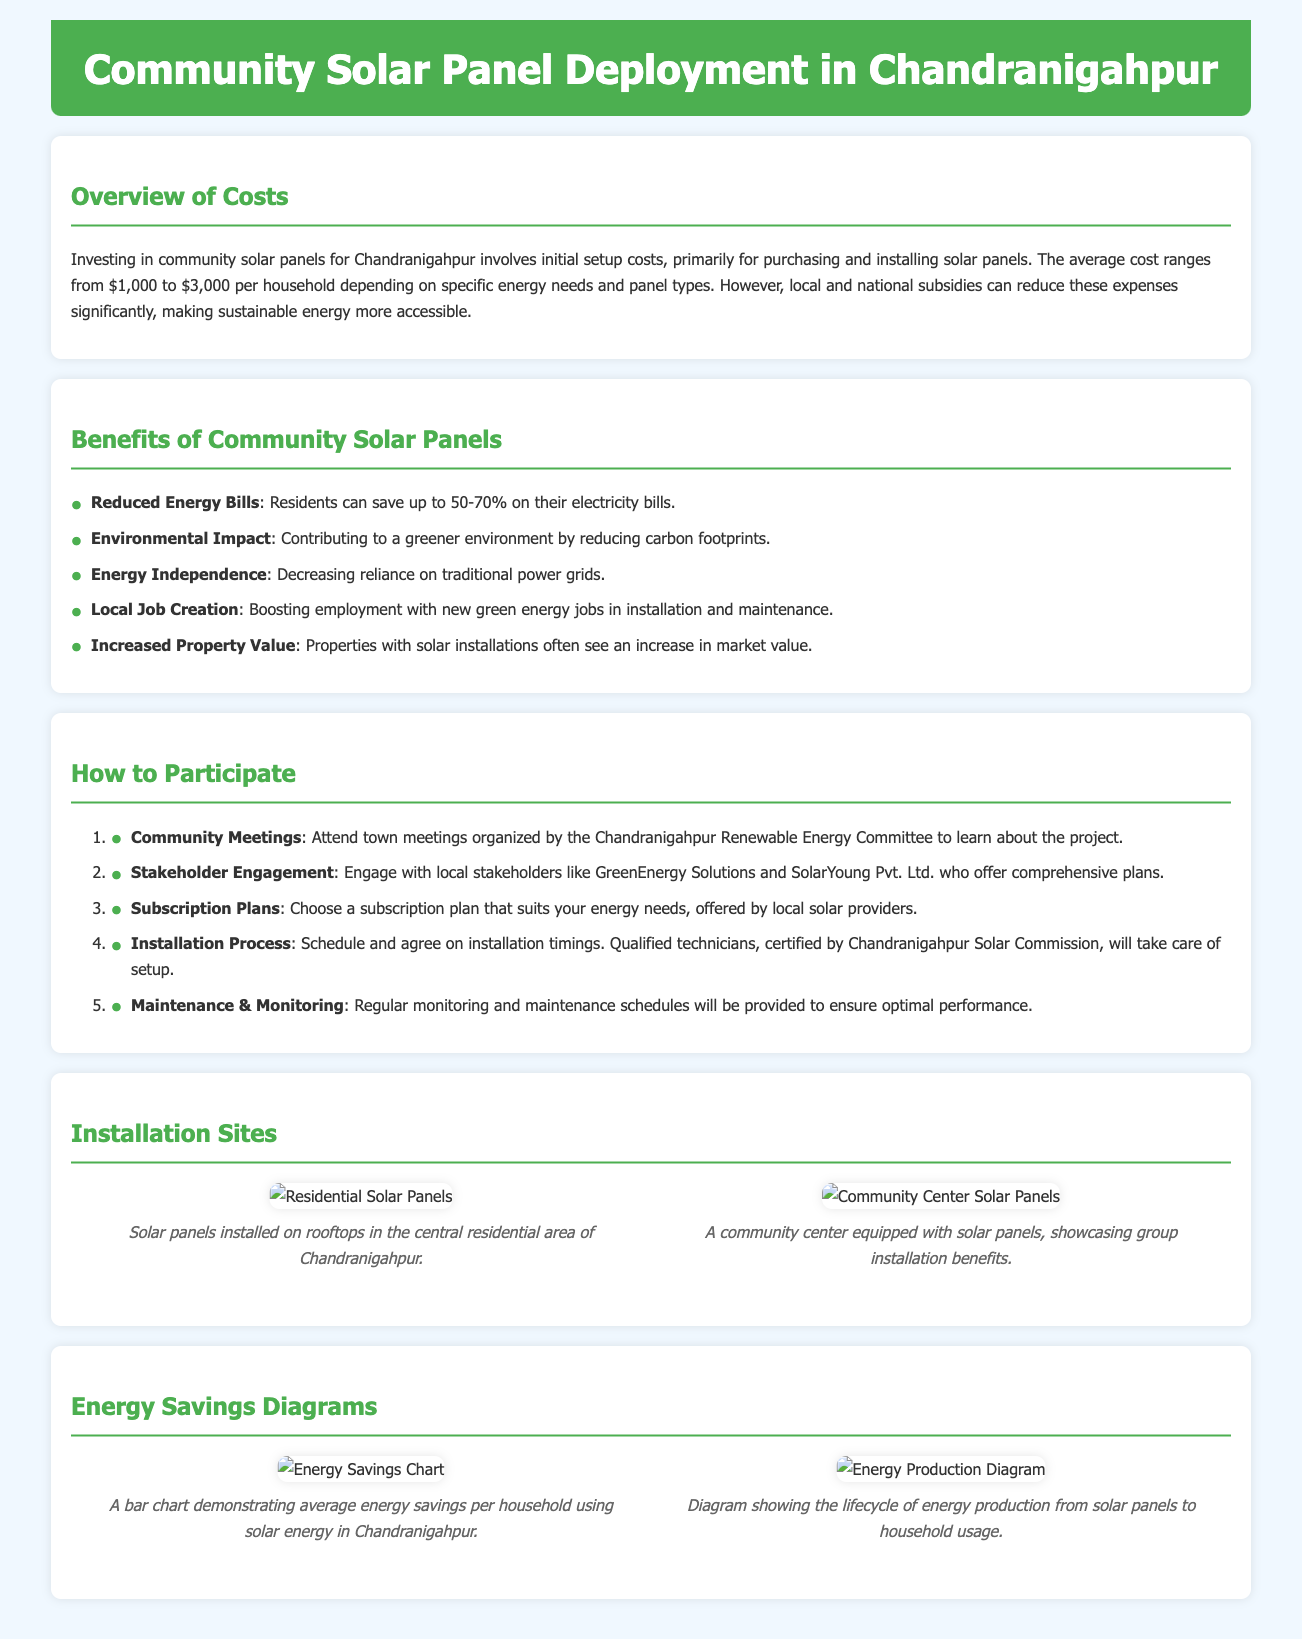What is the average cost range for solar panel installation per household? The average cost ranges from $1,000 to $3,000 per household depending on specific energy needs and panel types.
Answer: $1,000 to $3,000 How much can residents save on their electricity bills? Residents can save up to 50-70% on their electricity bills with the installation of solar panels.
Answer: 50-70% What is one benefit of community solar panels related to the environment? One of the benefits is contributing to a greener environment by reducing carbon footprints.
Answer: Reduced carbon footprints Who should residents engage with for stakeholder involvement? Residents should engage with local stakeholders like GreenEnergy Solutions and SolarYoung Pvt. Ltd. who offer comprehensive plans.
Answer: GreenEnergy Solutions and SolarYoung Pvt. Ltd What type of meetings should residents attend to participate? Residents should attend town meetings organized by the Chandranigahpur Renewable Energy Committee to learn about the project.
Answer: Town meetings What is one visual representation included in the document related to energy savings? The document includes a bar chart demonstrating average energy savings per household using solar energy in Chandranigahpur.
Answer: Bar chart What does the installation site image depict in the central residential area? The image depicts solar panels installed on rooftops in the central residential area of Chandranigahpur.
Answer: Rooftops with solar panels What is provided after installation for the solar panels? Regular monitoring and maintenance schedules will be provided to ensure optimal performance post-installation.
Answer: Maintenance schedules 